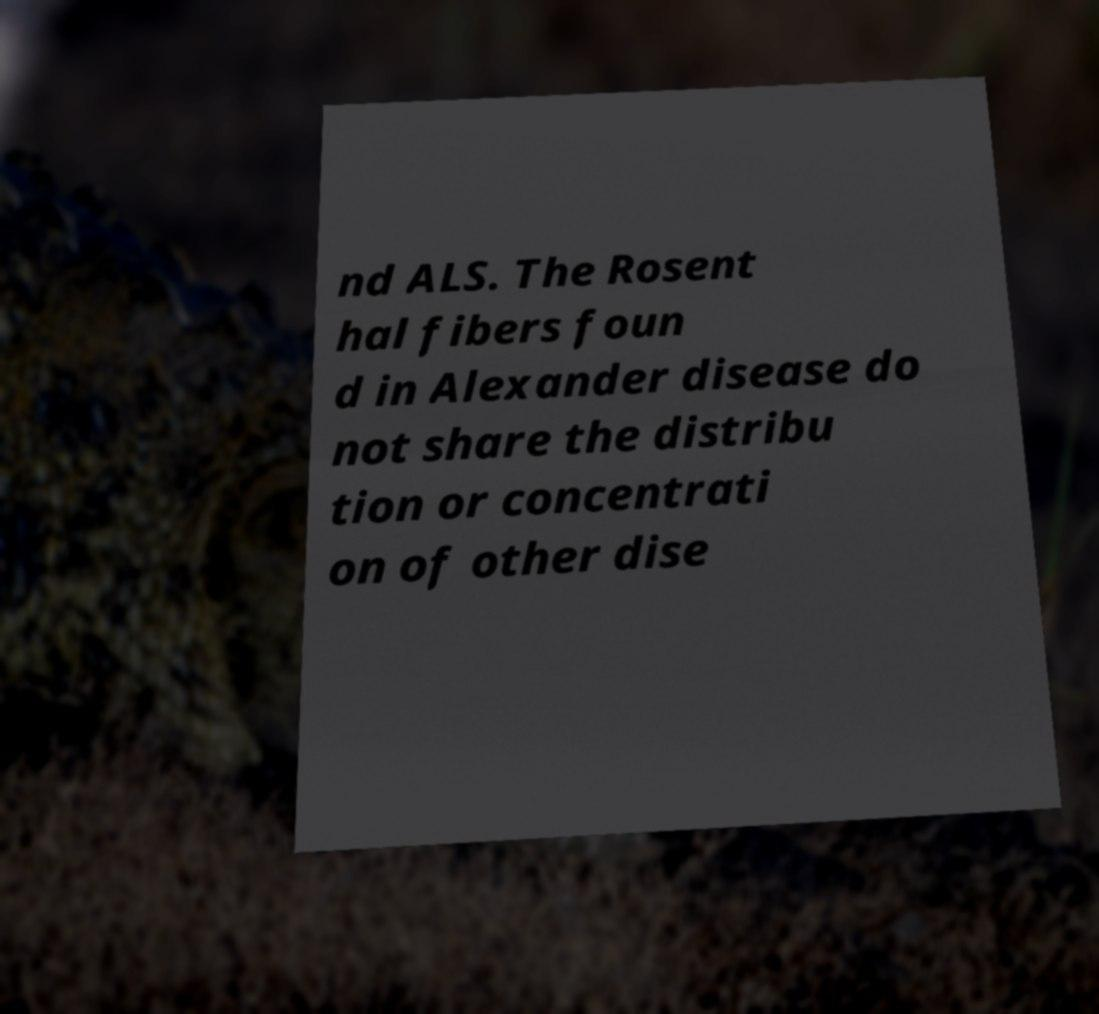Can you read and provide the text displayed in the image?This photo seems to have some interesting text. Can you extract and type it out for me? nd ALS. The Rosent hal fibers foun d in Alexander disease do not share the distribu tion or concentrati on of other dise 